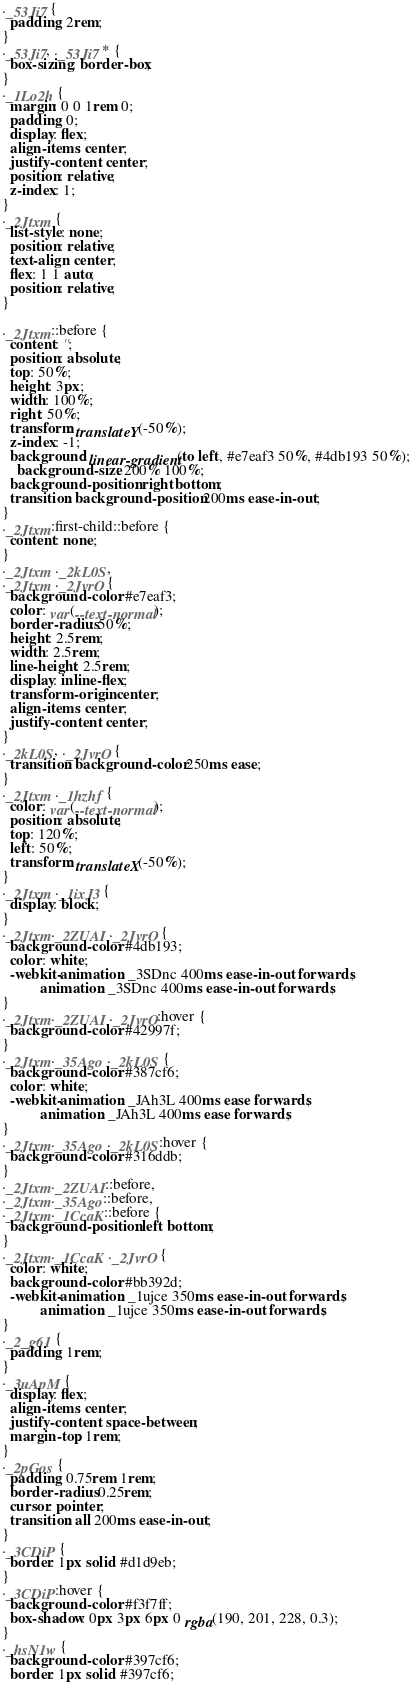<code> <loc_0><loc_0><loc_500><loc_500><_CSS_>._53Ji7 {
  padding: 2rem;
}
._53Ji7, ._53Ji7 * {
  box-sizing: border-box;
}
._1Lo2h {
  margin: 0 0 1rem 0;
  padding: 0;
  display: flex;
  align-items: center;
  justify-content: center;
  position: relative;
  z-index: 1;
}
._2Jtxm {
  list-style: none;
  position: relative;
  text-align: center;
  flex: 1 1 auto;
  position: relative;
}

._2Jtxm::before {
  content: '';
  position: absolute;
  top: 50%;
  height: 3px;
  width: 100%;
  right: 50%;
  transform: translateY(-50%);
  z-index: -1;
  background: linear-gradient(to left, #e7eaf3 50%, #4db193 50%);
	background-size: 200% 100%;
  background-position: right bottom;
  transition: background-position 200ms ease-in-out;
}
._2Jtxm:first-child::before {
  content: none;
}
._2Jtxm ._2kL0S,
._2Jtxm ._2JvrO {
  background-color: #e7eaf3;
  color: var(--text-normal);
  border-radius: 50%;
  height: 2.5rem;
  width: 2.5rem;
  line-height: 2.5rem;
  display: inline-flex;
  transform-origin: center;
  align-items: center;
  justify-content: center;
}
._2kL0S, ._2JvrO {
  transition: background-color 250ms ease;
}
._2Jtxm ._1hzhf {
  color: var(--text-normal);
  position: absolute;
  top: 120%;
  left: 50%;
  transform: translateX(-50%);
}
._2Jtxm ._1ixJ3 {
  display: block;
}
._2Jtxm._2ZUAI ._2JvrO {
  background-color: #4db193;
  color: white;
  -webkit-animation: _3SDnc 400ms ease-in-out forwards;
          animation: _3SDnc 400ms ease-in-out forwards;
}
._2Jtxm._2ZUAI ._2JvrO:hover {
  background-color: #42997f;
}
._2Jtxm._35Ago ._2kL0S {
  background-color: #387cf6;
  color: white;
  -webkit-animation: _JAh3L 400ms ease forwards;
          animation: _JAh3L 400ms ease forwards;
}
._2Jtxm._35Ago ._2kL0S:hover {
  background-color: #316ddb;
}
._2Jtxm._2ZUAI::before,
._2Jtxm._35Ago::before,
._2Jtxm._1CcaK::before {
  background-position: left bottom;
}
._2Jtxm._1CcaK ._2JvrO {
  color: white;
  background-color: #bb392d;
  -webkit-animation: _1ujce 350ms ease-in-out forwards;
          animation: _1ujce 350ms ease-in-out forwards;
}
._2_g61 {
  padding: 1rem;
}
._3uApM {
  display: flex;
  align-items: center;
  justify-content: space-between;
  margin-top: 1rem;
}
._2pGos {
  padding: 0.75rem 1rem;
  border-radius: 0.25rem;
  cursor: pointer;
  transition: all 200ms ease-in-out;
}
._3CDiP {
  border: 1px solid #d1d9eb;
}
._3CDiP:hover {
  background-color: #f3f7ff;
  box-shadow: 0px 3px 6px 0 rgba(190, 201, 228, 0.3);
}
._hsN1w {
  background-color: #397cf6;
  border: 1px solid #397cf6;</code> 